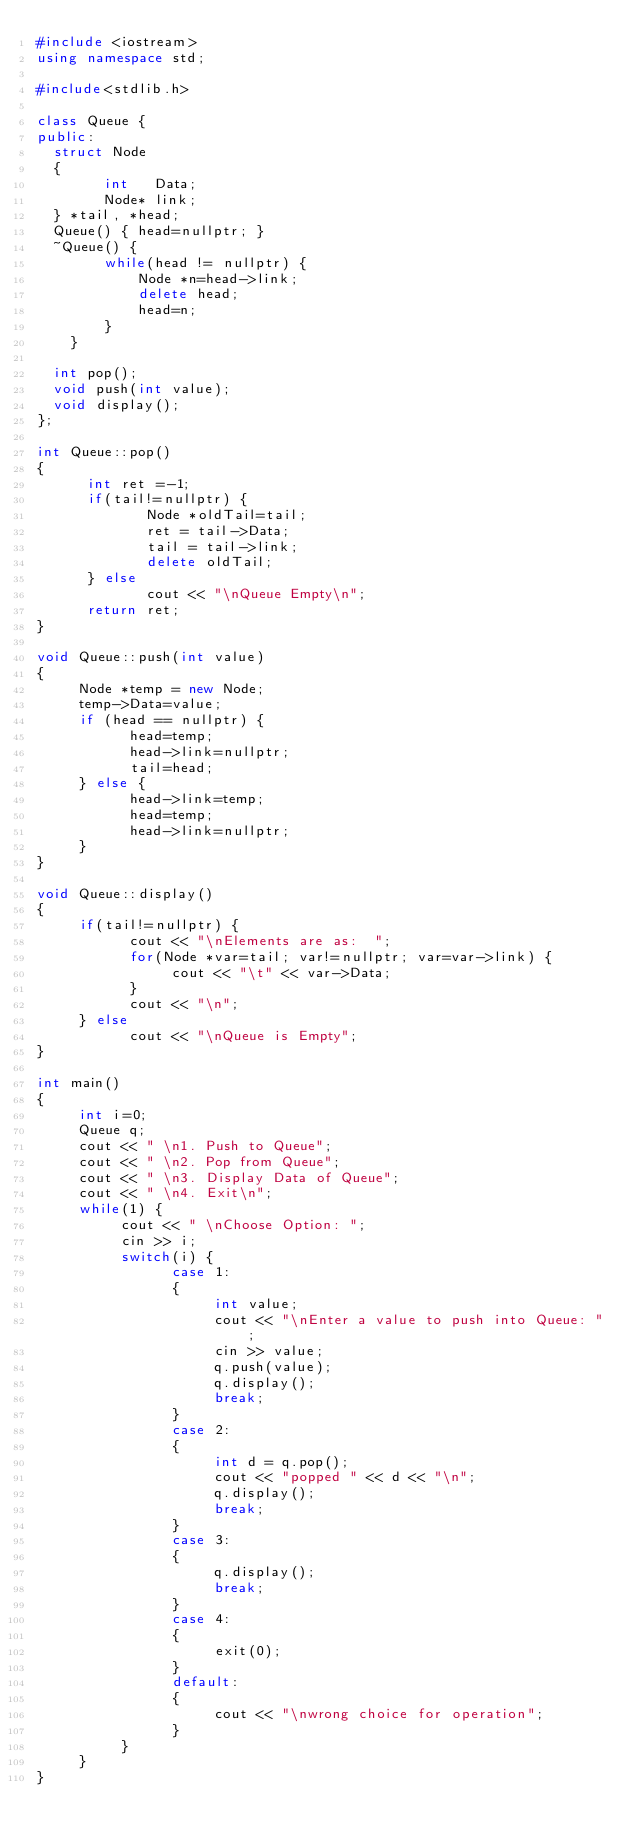Convert code to text. <code><loc_0><loc_0><loc_500><loc_500><_C++_>#include <iostream>
using namespace std;

#include<stdlib.h>

class Queue {
public:
  struct Node
  {
        int   Data;
        Node* link;
  } *tail, *head;
  Queue() { head=nullptr; }
  ~Queue() {
        while(head != nullptr) {
            Node *n=head->link;
            delete head;
            head=n;
        }
    }

  int pop();
  void push(int value);
  void display();
};

int Queue::pop()
{
      int ret =-1;
      if(tail!=nullptr) {
             Node *oldTail=tail;
             ret = tail->Data;
             tail = tail->link;
             delete oldTail;
      } else
             cout << "\nQueue Empty\n";
      return ret;
}

void Queue::push(int value)
{
     Node *temp = new Node;
     temp->Data=value;
     if (head == nullptr) {
           head=temp;
           head->link=nullptr;
           tail=head;
     } else {
           head->link=temp;
           head=temp;
           head->link=nullptr;
     }
}

void Queue::display()
{
     if(tail!=nullptr) {
           cout << "\nElements are as:  ";
           for(Node *var=tail; var!=nullptr; var=var->link) {
                cout << "\t" << var->Data;
           }
           cout << "\n";
     } else
           cout << "\nQueue is Empty";
}

int main()
{
     int i=0;
     Queue q;
     cout << " \n1. Push to Queue";
     cout << " \n2. Pop from Queue";
     cout << " \n3. Display Data of Queue";
     cout << " \n4. Exit\n";
     while(1) {
          cout << " \nChoose Option: ";
          cin >> i;
          switch(i) {
                case 1:
                {
                     int value;
                     cout << "\nEnter a value to push into Queue: ";
                     cin >> value;
                     q.push(value);
                     q.display();
                     break;
                }
                case 2:
                {
                     int d = q.pop();
                     cout << "popped " << d << "\n";
                     q.display();
                     break;
                }
                case 3:
                {
                     q.display();
                     break;
                }
                case 4:
                {
                     exit(0);
                }
                default:
                {
                     cout << "\nwrong choice for operation";
                }
          }
     }
}
</code> 